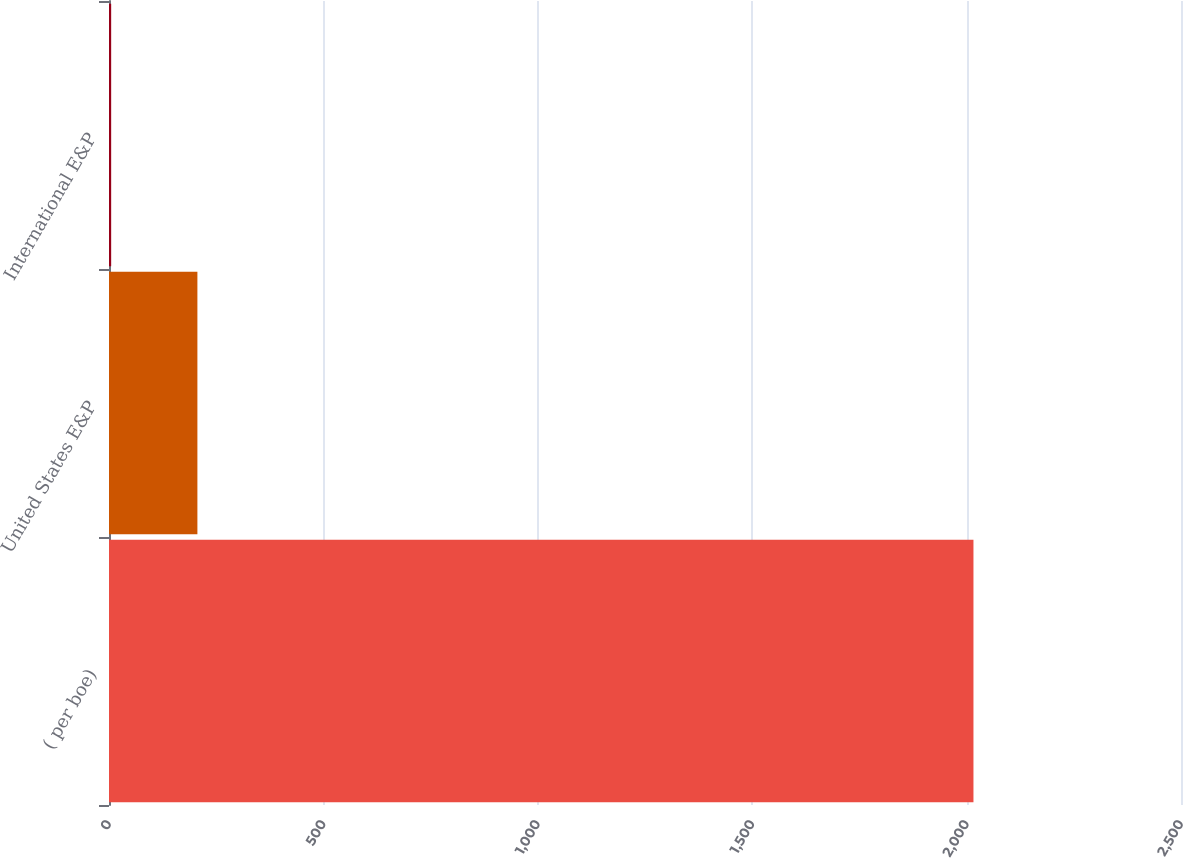Convert chart to OTSL. <chart><loc_0><loc_0><loc_500><loc_500><bar_chart><fcel>( per boe)<fcel>United States E&P<fcel>International E&P<nl><fcel>2016<fcel>206.15<fcel>5.05<nl></chart> 